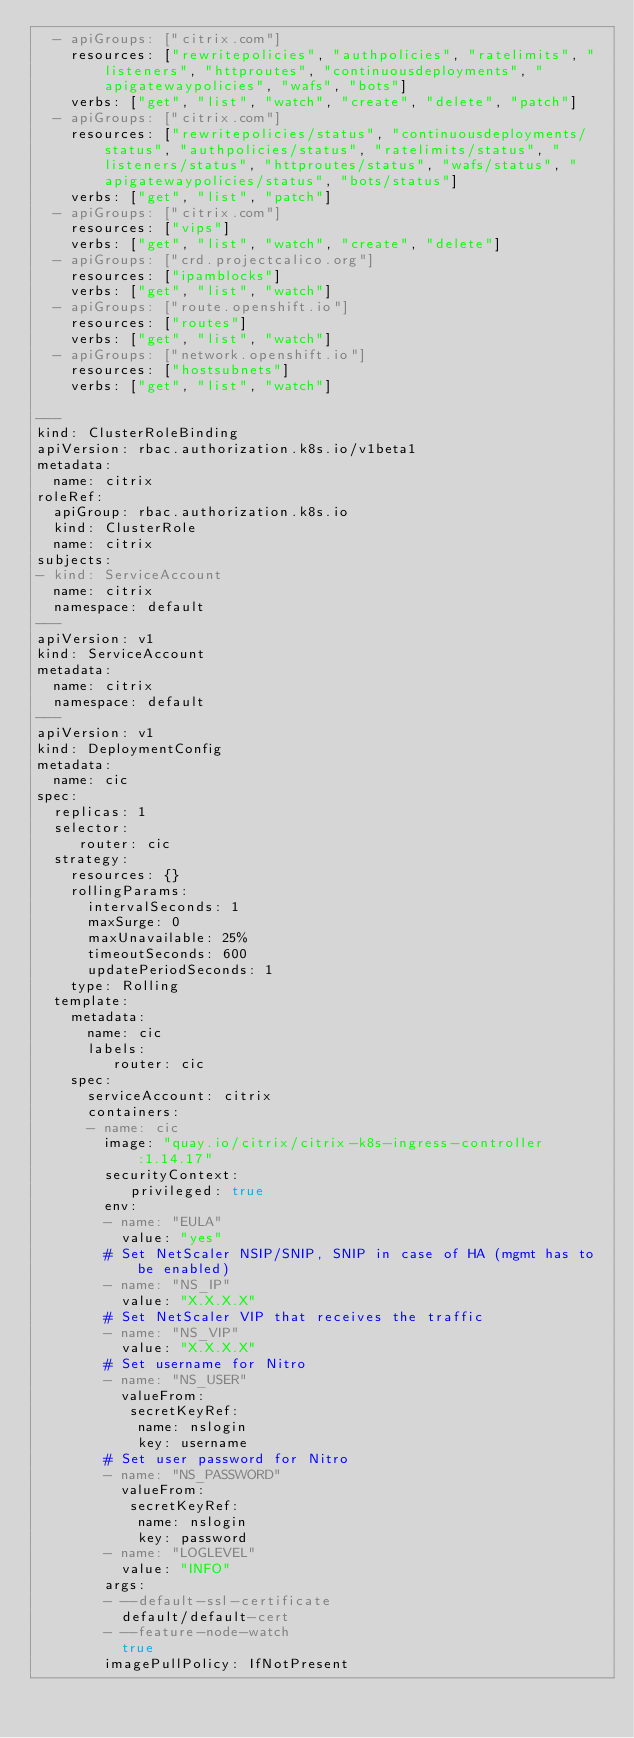<code> <loc_0><loc_0><loc_500><loc_500><_YAML_>  - apiGroups: ["citrix.com"]
    resources: ["rewritepolicies", "authpolicies", "ratelimits", "listeners", "httproutes", "continuousdeployments", "apigatewaypolicies", "wafs", "bots"]
    verbs: ["get", "list", "watch", "create", "delete", "patch"]
  - apiGroups: ["citrix.com"]
    resources: ["rewritepolicies/status", "continuousdeployments/status", "authpolicies/status", "ratelimits/status", "listeners/status", "httproutes/status", "wafs/status", "apigatewaypolicies/status", "bots/status"]
    verbs: ["get", "list", "patch"]
  - apiGroups: ["citrix.com"]
    resources: ["vips"]
    verbs: ["get", "list", "watch", "create", "delete"]
  - apiGroups: ["crd.projectcalico.org"]
    resources: ["ipamblocks"]
    verbs: ["get", "list", "watch"]
  - apiGroups: ["route.openshift.io"]
    resources: ["routes"]
    verbs: ["get", "list", "watch"]
  - apiGroups: ["network.openshift.io"]
    resources: ["hostsubnets"]
    verbs: ["get", "list", "watch"]

---
kind: ClusterRoleBinding
apiVersion: rbac.authorization.k8s.io/v1beta1
metadata:
  name: citrix
roleRef:
  apiGroup: rbac.authorization.k8s.io
  kind: ClusterRole
  name: citrix
subjects:
- kind: ServiceAccount
  name: citrix
  namespace: default
---
apiVersion: v1
kind: ServiceAccount
metadata:
  name: citrix
  namespace: default
---
apiVersion: v1
kind: DeploymentConfig
metadata:
  name: cic
spec:
  replicas: 1
  selector:
     router: cic
  strategy:
    resources: {}
    rollingParams:
      intervalSeconds: 1
      maxSurge: 0
      maxUnavailable: 25%
      timeoutSeconds: 600
      updatePeriodSeconds: 1
    type: Rolling
  template:
    metadata:
      name: cic
      labels:
         router: cic
    spec:
      serviceAccount: citrix
      containers:
      - name: cic
        image: "quay.io/citrix/citrix-k8s-ingress-controller:1.14.17"
        securityContext:
           privileged: true
        env:
        - name: "EULA"
          value: "yes"
        # Set NetScaler NSIP/SNIP, SNIP in case of HA (mgmt has to be enabled)
        - name: "NS_IP"
          value: "X.X.X.X"
        # Set NetScaler VIP that receives the traffic
        - name: "NS_VIP"
          value: "X.X.X.X"
        # Set username for Nitro
        - name: "NS_USER"
          valueFrom:
           secretKeyRef:
            name: nslogin
            key: username
        # Set user password for Nitro
        - name: "NS_PASSWORD"
          valueFrom:
           secretKeyRef:
            name: nslogin
            key: password
        - name: "LOGLEVEL"
          value: "INFO"
        args:
        - --default-ssl-certificate
          default/default-cert
        - --feature-node-watch
          true
        imagePullPolicy: IfNotPresent
</code> 